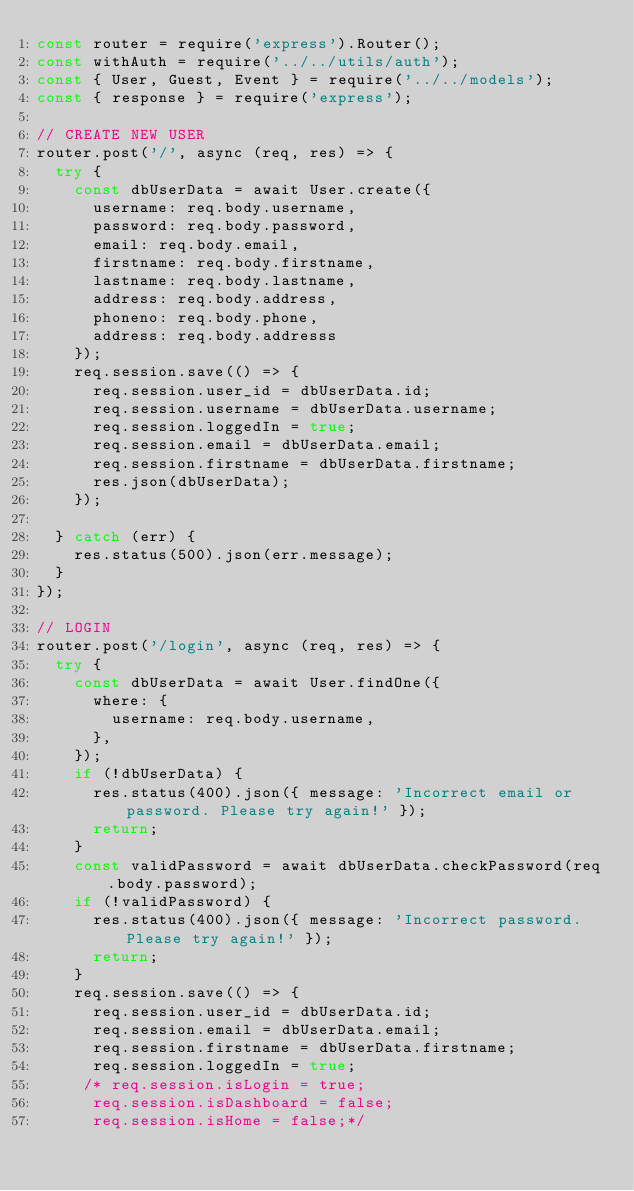Convert code to text. <code><loc_0><loc_0><loc_500><loc_500><_JavaScript_>const router = require('express').Router();
const withAuth = require('../../utils/auth');
const { User, Guest, Event } = require('../../models');
const { response } = require('express');

// CREATE NEW USER
router.post('/', async (req, res) => {
  try {
    const dbUserData = await User.create({
      username: req.body.username,
      password: req.body.password,
      email: req.body.email,
      firstname: req.body.firstname,
      lastname: req.body.lastname,
      address: req.body.address,
      phoneno: req.body.phone,
      address: req.body.addresss
    });
    req.session.save(() => {
      req.session.user_id = dbUserData.id;
      req.session.username = dbUserData.username;
      req.session.loggedIn = true;
      req.session.email = dbUserData.email;
      req.session.firstname = dbUserData.firstname;
      res.json(dbUserData);
    });

  } catch (err) {
    res.status(500).json(err.message);
  }
});

// LOGIN 
router.post('/login', async (req, res) => {
  try {
    const dbUserData = await User.findOne({
      where: {
        username: req.body.username,
      },
    });    
    if (!dbUserData) {
      res.status(400).json({ message: 'Incorrect email or password. Please try again!' });
      return;
    }
    const validPassword = await dbUserData.checkPassword(req.body.password);
    if (!validPassword) {
      res.status(400).json({ message: 'Incorrect password. Please try again!' });
      return;
    }
    req.session.save(() => {
      req.session.user_id = dbUserData.id;
      req.session.email = dbUserData.email;
      req.session.firstname = dbUserData.firstname;
      req.session.loggedIn = true;
     /* req.session.isLogin = true;
      req.session.isDashboard = false;
      req.session.isHome = false;*/
</code> 